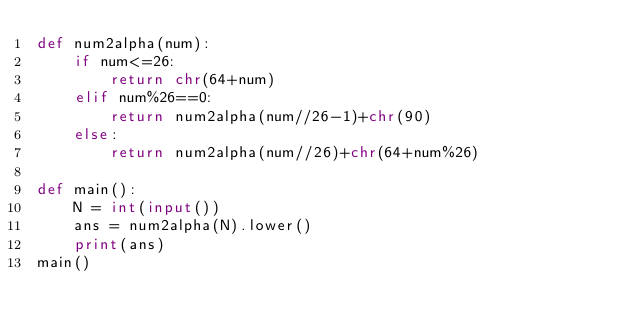Convert code to text. <code><loc_0><loc_0><loc_500><loc_500><_Python_>def num2alpha(num):
    if num<=26:
        return chr(64+num)
    elif num%26==0:
        return num2alpha(num//26-1)+chr(90)
    else:
        return num2alpha(num//26)+chr(64+num%26)
    
def main():
    N = int(input())
    ans = num2alpha(N).lower()
    print(ans)
main()</code> 